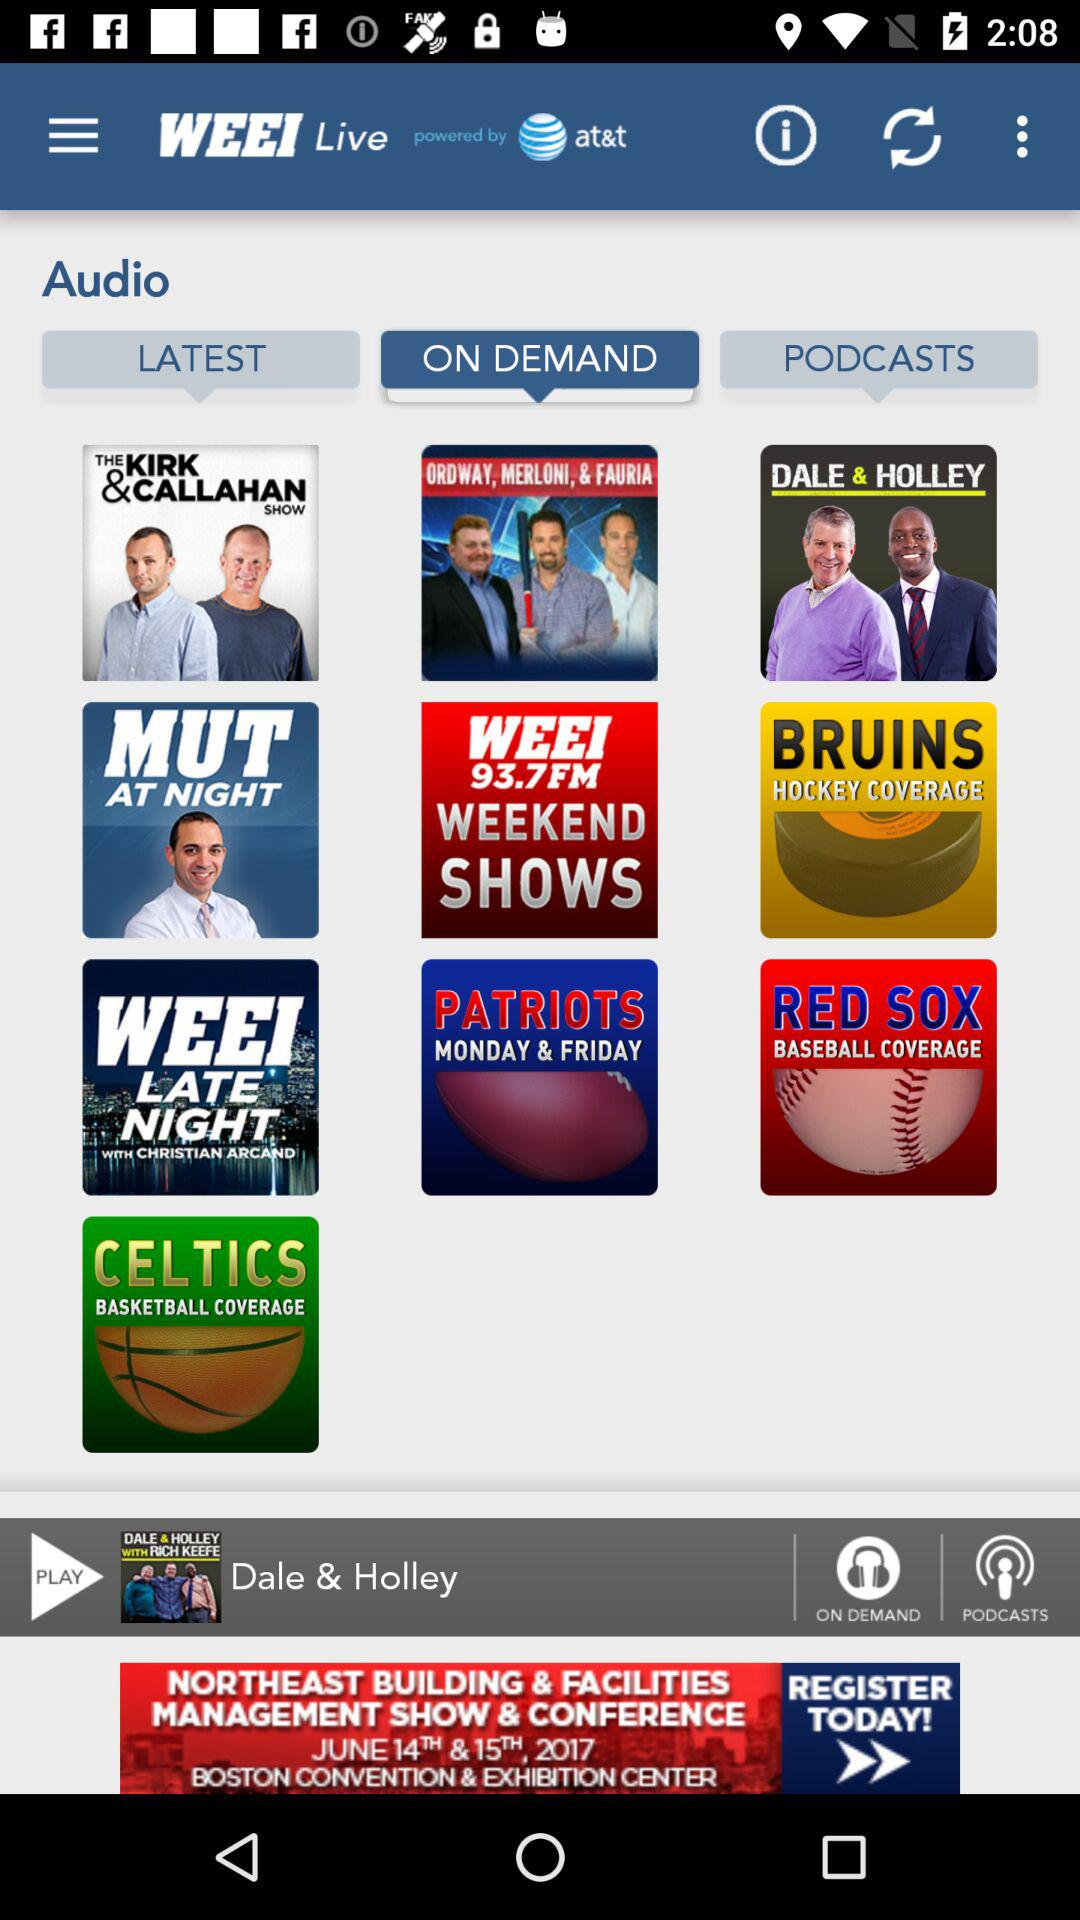What is the name of the application? The name of the application is "WEEI Live". 